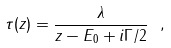<formula> <loc_0><loc_0><loc_500><loc_500>\tau ( z ) = \frac { \lambda } { z - E _ { 0 } + i \Gamma / 2 } \ ,</formula> 